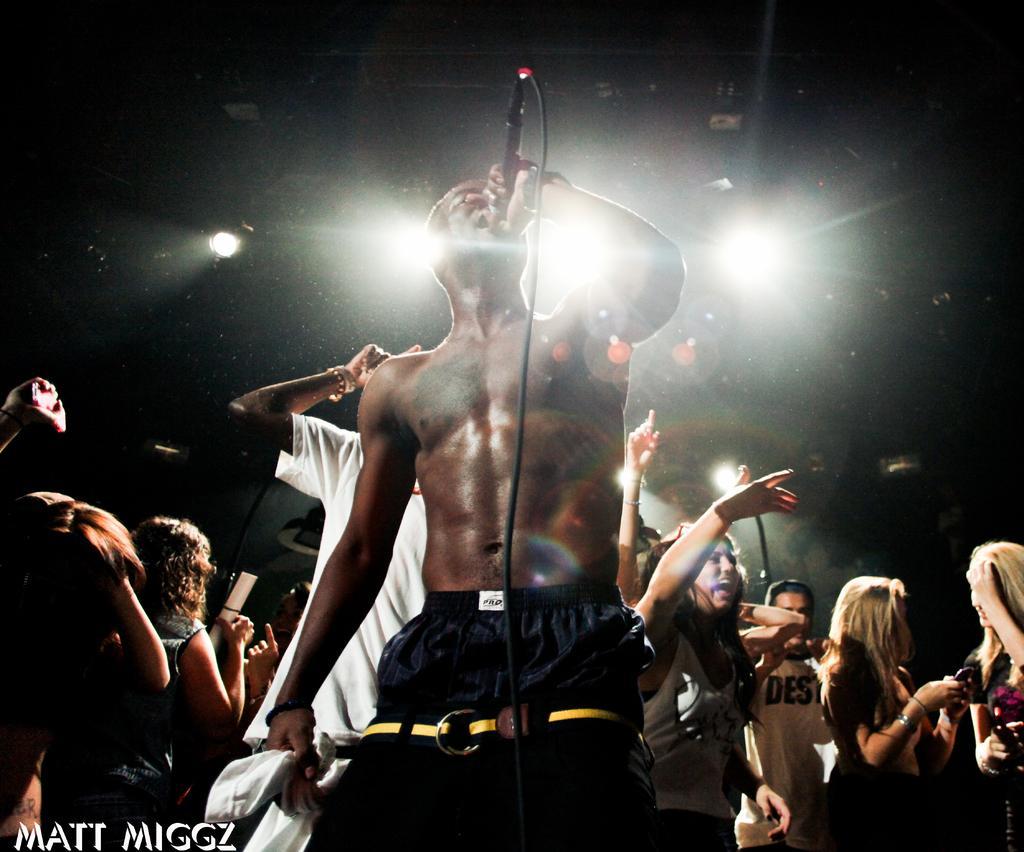Please provide a concise description of this image. In this picture I can see group of people are standing. Here I can see a man is standing and holding a microphone. In the background I can see lights. 